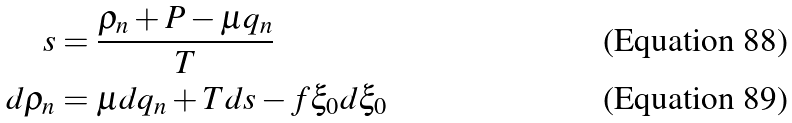<formula> <loc_0><loc_0><loc_500><loc_500>s & = \frac { \rho _ { n } + P - \mu q _ { n } } { T } \\ d \rho _ { n } & = \mu d q _ { n } + T d s - f \xi _ { 0 } d \xi _ { 0 }</formula> 